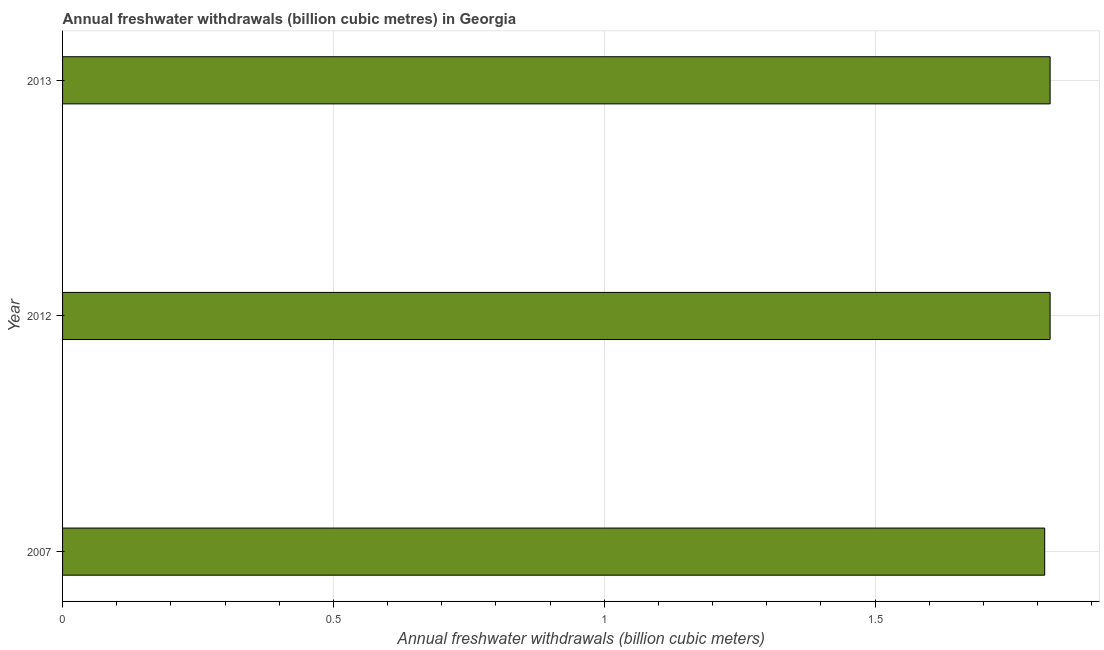What is the title of the graph?
Give a very brief answer. Annual freshwater withdrawals (billion cubic metres) in Georgia. What is the label or title of the X-axis?
Your answer should be very brief. Annual freshwater withdrawals (billion cubic meters). What is the annual freshwater withdrawals in 2007?
Keep it short and to the point. 1.81. Across all years, what is the maximum annual freshwater withdrawals?
Offer a very short reply. 1.82. Across all years, what is the minimum annual freshwater withdrawals?
Ensure brevity in your answer.  1.81. In which year was the annual freshwater withdrawals maximum?
Provide a short and direct response. 2012. In which year was the annual freshwater withdrawals minimum?
Keep it short and to the point. 2007. What is the sum of the annual freshwater withdrawals?
Give a very brief answer. 5.46. What is the difference between the annual freshwater withdrawals in 2007 and 2013?
Your answer should be very brief. -0.01. What is the average annual freshwater withdrawals per year?
Your answer should be very brief. 1.82. What is the median annual freshwater withdrawals?
Ensure brevity in your answer.  1.82. In how many years, is the annual freshwater withdrawals greater than 0.3 billion cubic meters?
Ensure brevity in your answer.  3. Do a majority of the years between 2013 and 2012 (inclusive) have annual freshwater withdrawals greater than 0.9 billion cubic meters?
Ensure brevity in your answer.  No. What is the ratio of the annual freshwater withdrawals in 2007 to that in 2012?
Give a very brief answer. 0.99. Is the sum of the annual freshwater withdrawals in 2007 and 2013 greater than the maximum annual freshwater withdrawals across all years?
Keep it short and to the point. Yes. How many bars are there?
Keep it short and to the point. 3. How many years are there in the graph?
Provide a short and direct response. 3. Are the values on the major ticks of X-axis written in scientific E-notation?
Keep it short and to the point. No. What is the Annual freshwater withdrawals (billion cubic meters) of 2007?
Your answer should be very brief. 1.81. What is the Annual freshwater withdrawals (billion cubic meters) in 2012?
Your answer should be compact. 1.82. What is the Annual freshwater withdrawals (billion cubic meters) in 2013?
Offer a very short reply. 1.82. What is the difference between the Annual freshwater withdrawals (billion cubic meters) in 2007 and 2012?
Your answer should be very brief. -0.01. What is the difference between the Annual freshwater withdrawals (billion cubic meters) in 2007 and 2013?
Offer a very short reply. -0.01. What is the difference between the Annual freshwater withdrawals (billion cubic meters) in 2012 and 2013?
Your response must be concise. 0. What is the ratio of the Annual freshwater withdrawals (billion cubic meters) in 2007 to that in 2012?
Your answer should be compact. 0.99. What is the ratio of the Annual freshwater withdrawals (billion cubic meters) in 2007 to that in 2013?
Your response must be concise. 0.99. 